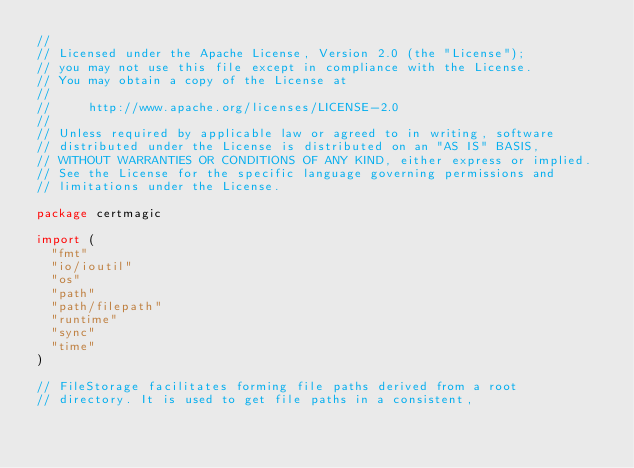<code> <loc_0><loc_0><loc_500><loc_500><_Go_>//
// Licensed under the Apache License, Version 2.0 (the "License");
// you may not use this file except in compliance with the License.
// You may obtain a copy of the License at
//
//     http://www.apache.org/licenses/LICENSE-2.0
//
// Unless required by applicable law or agreed to in writing, software
// distributed under the License is distributed on an "AS IS" BASIS,
// WITHOUT WARRANTIES OR CONDITIONS OF ANY KIND, either express or implied.
// See the License for the specific language governing permissions and
// limitations under the License.

package certmagic

import (
	"fmt"
	"io/ioutil"
	"os"
	"path"
	"path/filepath"
	"runtime"
	"sync"
	"time"
)

// FileStorage facilitates forming file paths derived from a root
// directory. It is used to get file paths in a consistent,</code> 